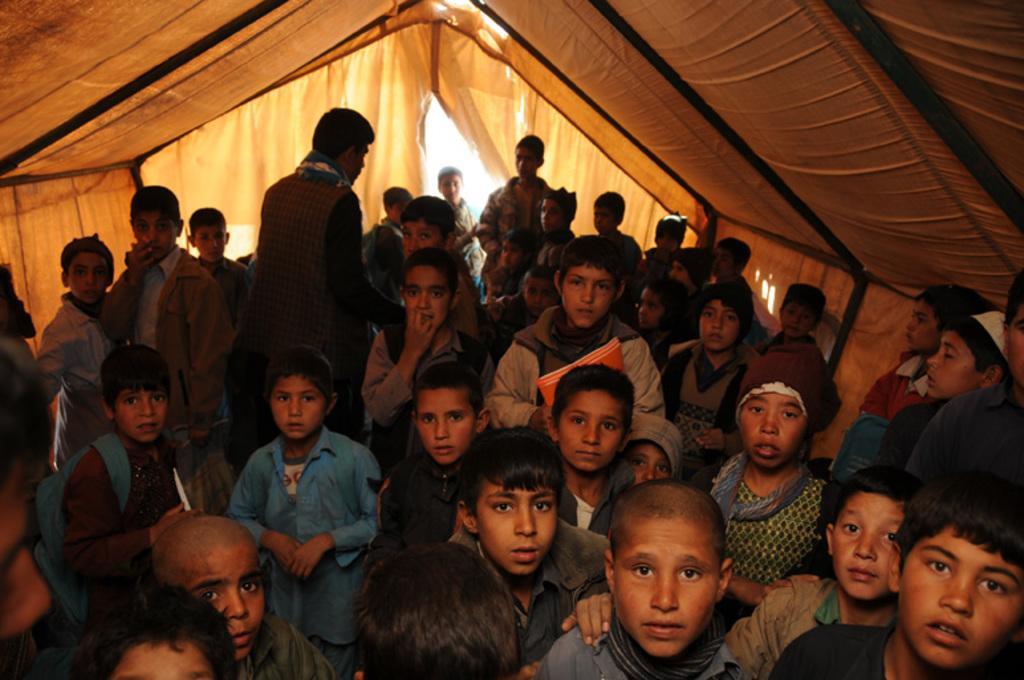How would you summarize this image in a sentence or two? In this picture we can see a group of people in a tent and some objects. 